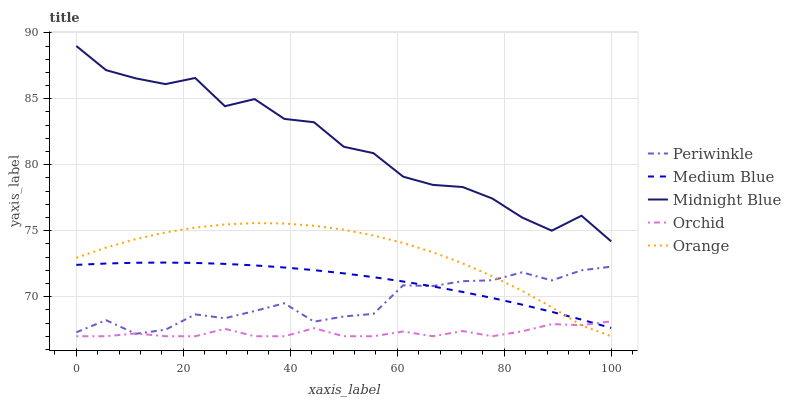Does Orchid have the minimum area under the curve?
Answer yes or no. Yes. Does Midnight Blue have the maximum area under the curve?
Answer yes or no. Yes. Does Medium Blue have the minimum area under the curve?
Answer yes or no. No. Does Medium Blue have the maximum area under the curve?
Answer yes or no. No. Is Medium Blue the smoothest?
Answer yes or no. Yes. Is Midnight Blue the roughest?
Answer yes or no. Yes. Is Periwinkle the smoothest?
Answer yes or no. No. Is Periwinkle the roughest?
Answer yes or no. No. Does Orange have the lowest value?
Answer yes or no. Yes. Does Medium Blue have the lowest value?
Answer yes or no. No. Does Midnight Blue have the highest value?
Answer yes or no. Yes. Does Medium Blue have the highest value?
Answer yes or no. No. Is Orange less than Midnight Blue?
Answer yes or no. Yes. Is Midnight Blue greater than Periwinkle?
Answer yes or no. Yes. Does Periwinkle intersect Orchid?
Answer yes or no. Yes. Is Periwinkle less than Orchid?
Answer yes or no. No. Is Periwinkle greater than Orchid?
Answer yes or no. No. Does Orange intersect Midnight Blue?
Answer yes or no. No. 